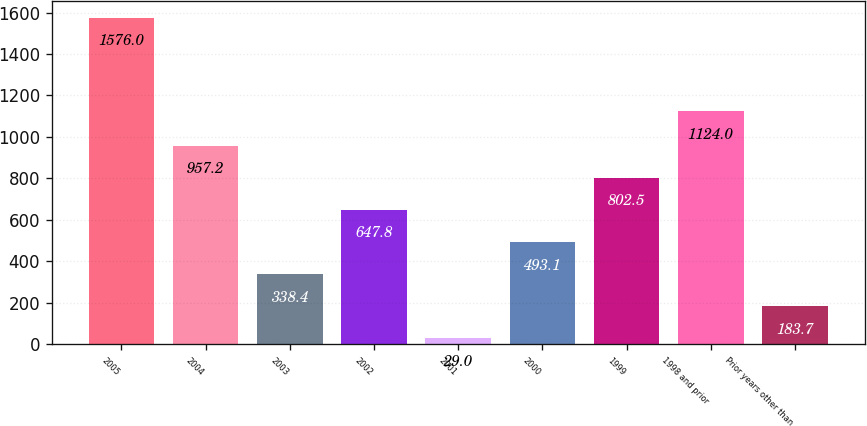Convert chart to OTSL. <chart><loc_0><loc_0><loc_500><loc_500><bar_chart><fcel>2005<fcel>2004<fcel>2003<fcel>2002<fcel>2001<fcel>2000<fcel>1999<fcel>1998 and prior<fcel>Prior years other than<nl><fcel>1576<fcel>957.2<fcel>338.4<fcel>647.8<fcel>29<fcel>493.1<fcel>802.5<fcel>1124<fcel>183.7<nl></chart> 